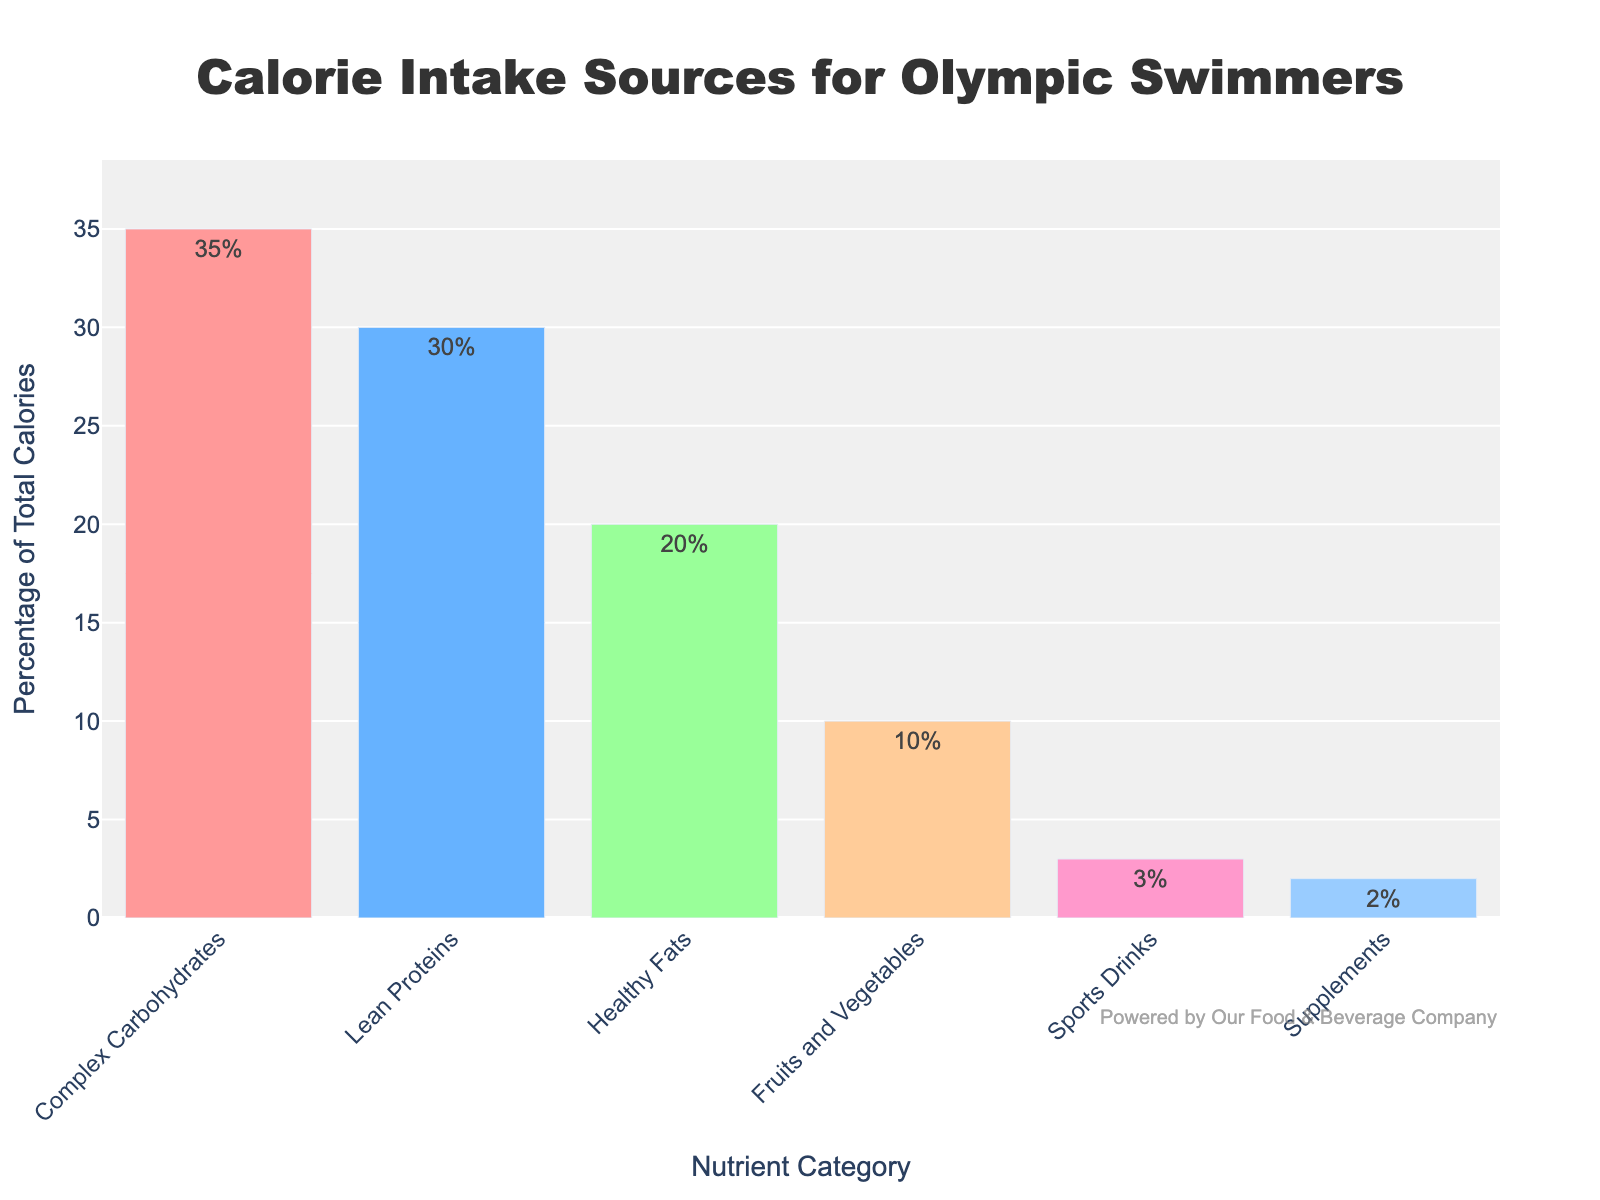what percentage of calorie intake comes from lean proteins? The percentage of calorie intake from lean proteins can be directly observed on the bar chart. The figure shows the 'Lean Proteins' category with a percentage label of 30%.
Answer: 30% how much higher is the intake of complex carbohydrates compared to sports drinks? To find the difference between complex carbohydrates and sports drinks, subtract the percentage for sports drinks from the percentage for complex carbohydrates. 35% (Complex Carbohydrates) - 3% (Sports Drinks) = 32%
Answer: 32% what is the combined percentage of calorie intake from healthy fats and fruits and vegetables? Add the percentages of healthy fats and fruits and vegetables. Healthy Fats: 20%, Fruits and Vegetables: 10%. Combined: 20% + 10% = 30%
Answer: 30% which category has the lowest percentage of calorie intake? By observing the heights of the bars and the corresponding percentage values, the category with the lowest height and value is 'Supplements' with 2%.
Answer: Supplements which two categories together contribute 50% of the total calorie intake? Find two categories whose percentages add up to 50%. Complex Carbohydrates (35%) + Lean Proteins (30%) is greater than 50%. Complex Carbohydrates (35%) + Healthy Fats (20%) is greater than 50%. Lean Proteins (30%) + Healthy Fats (20%) add up exactly to 50%.
Answer: Lean Proteins and Healthy Fats 